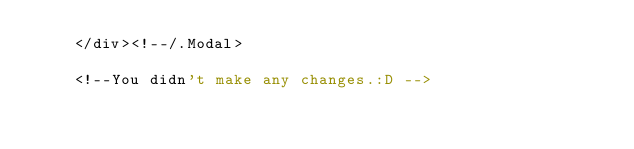Convert code to text. <code><loc_0><loc_0><loc_500><loc_500><_PHP_>	</div><!--/.Modal>
    
    <!--You didn't make any changes.:D --></code> 